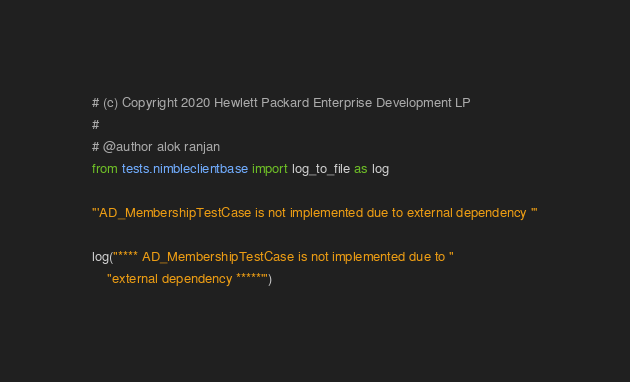<code> <loc_0><loc_0><loc_500><loc_500><_Python_># (c) Copyright 2020 Hewlett Packard Enterprise Development LP
#
# @author alok ranjan
from tests.nimbleclientbase import log_to_file as log

'''AD_MembershipTestCase is not implemented due to external dependency '''

log("**** AD_MembershipTestCase is not implemented due to "
    "external dependency *****'")
</code> 